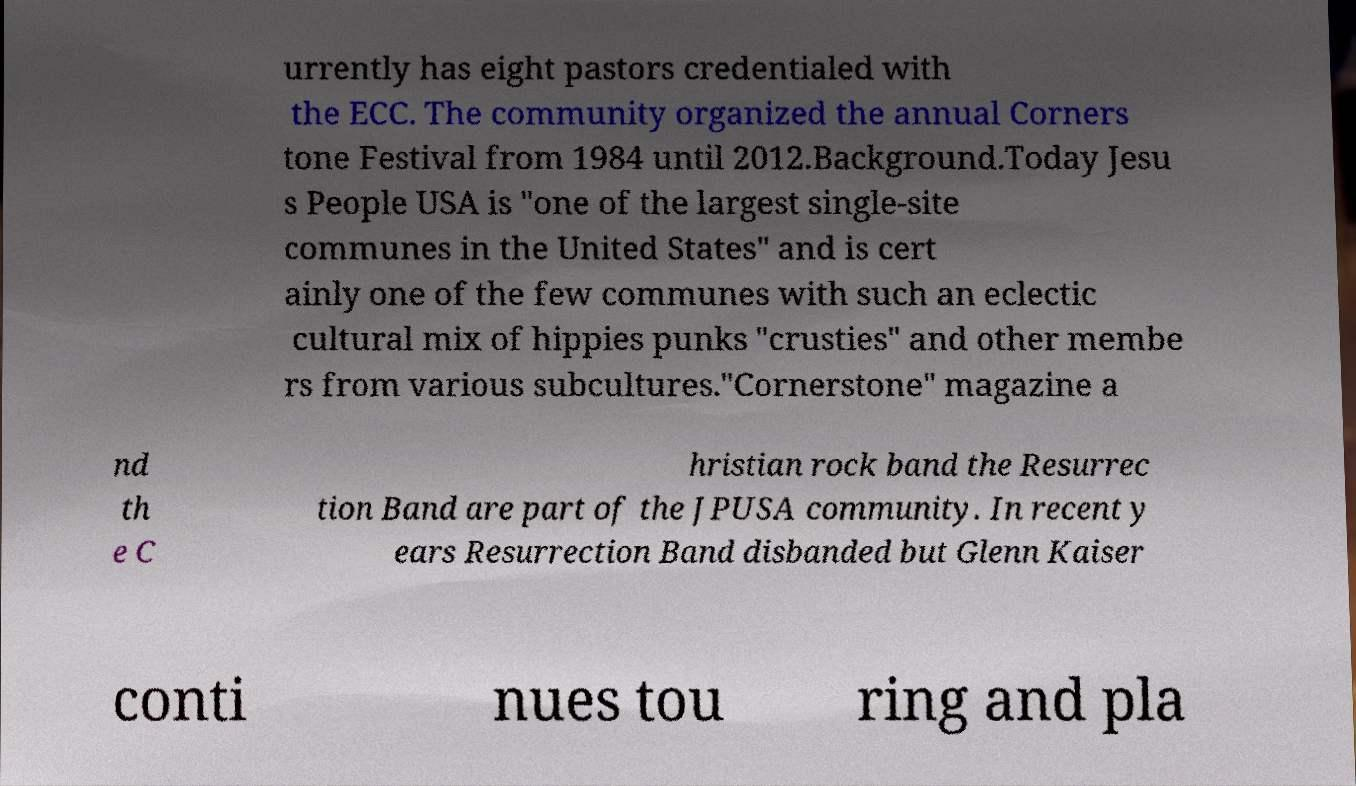Can you accurately transcribe the text from the provided image for me? urrently has eight pastors credentialed with the ECC. The community organized the annual Corners tone Festival from 1984 until 2012.Background.Today Jesu s People USA is "one of the largest single-site communes in the United States" and is cert ainly one of the few communes with such an eclectic cultural mix of hippies punks "crusties" and other membe rs from various subcultures."Cornerstone" magazine a nd th e C hristian rock band the Resurrec tion Band are part of the JPUSA community. In recent y ears Resurrection Band disbanded but Glenn Kaiser conti nues tou ring and pla 